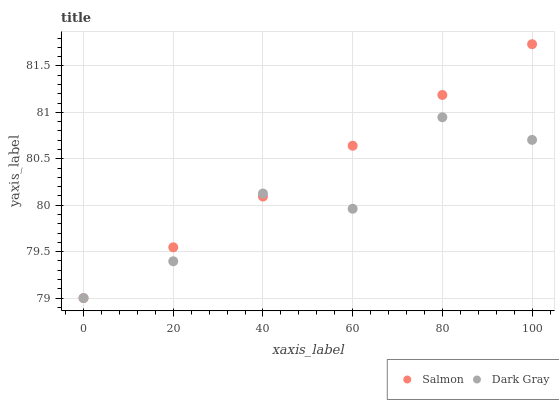Does Dark Gray have the minimum area under the curve?
Answer yes or no. Yes. Does Salmon have the maximum area under the curve?
Answer yes or no. Yes. Does Salmon have the minimum area under the curve?
Answer yes or no. No. Is Salmon the smoothest?
Answer yes or no. Yes. Is Dark Gray the roughest?
Answer yes or no. Yes. Is Salmon the roughest?
Answer yes or no. No. Does Dark Gray have the lowest value?
Answer yes or no. Yes. Does Salmon have the highest value?
Answer yes or no. Yes. Does Salmon intersect Dark Gray?
Answer yes or no. Yes. Is Salmon less than Dark Gray?
Answer yes or no. No. Is Salmon greater than Dark Gray?
Answer yes or no. No. 